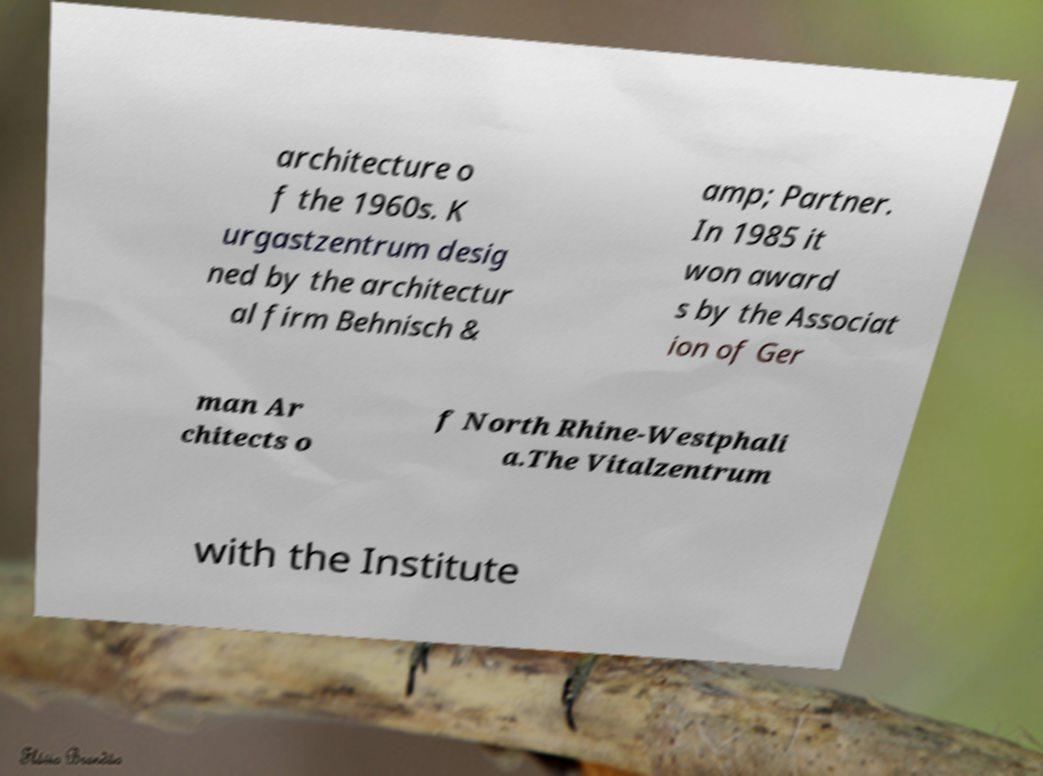There's text embedded in this image that I need extracted. Can you transcribe it verbatim? architecture o f the 1960s. K urgastzentrum desig ned by the architectur al firm Behnisch & amp; Partner. In 1985 it won award s by the Associat ion of Ger man Ar chitects o f North Rhine-Westphali a.The Vitalzentrum with the Institute 